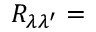<formula> <loc_0><loc_0><loc_500><loc_500>R _ { \lambda \lambda ^ { \prime } } =</formula> 